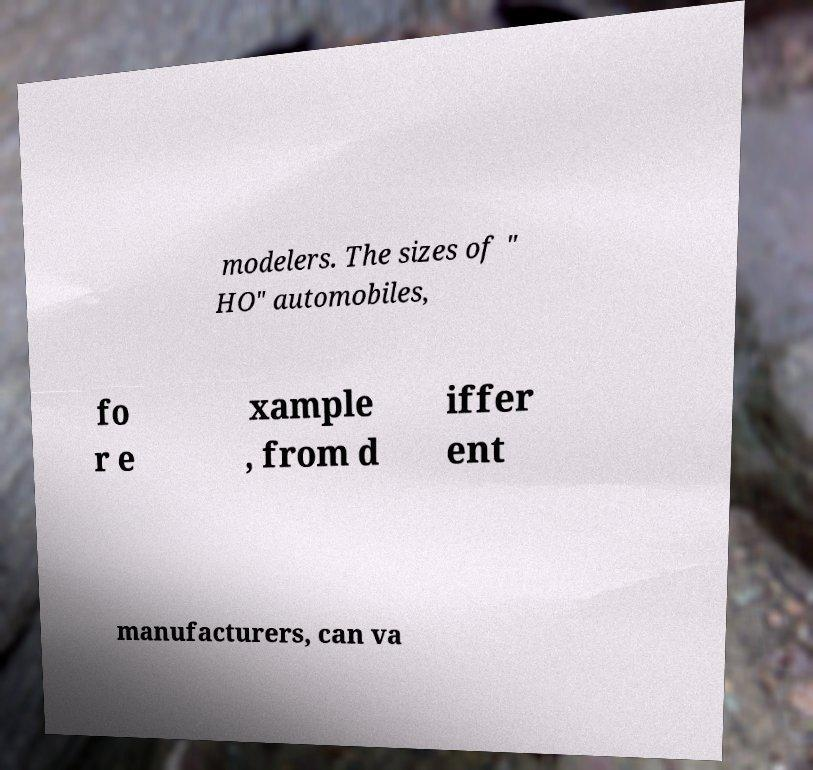I need the written content from this picture converted into text. Can you do that? modelers. The sizes of " HO" automobiles, fo r e xample , from d iffer ent manufacturers, can va 